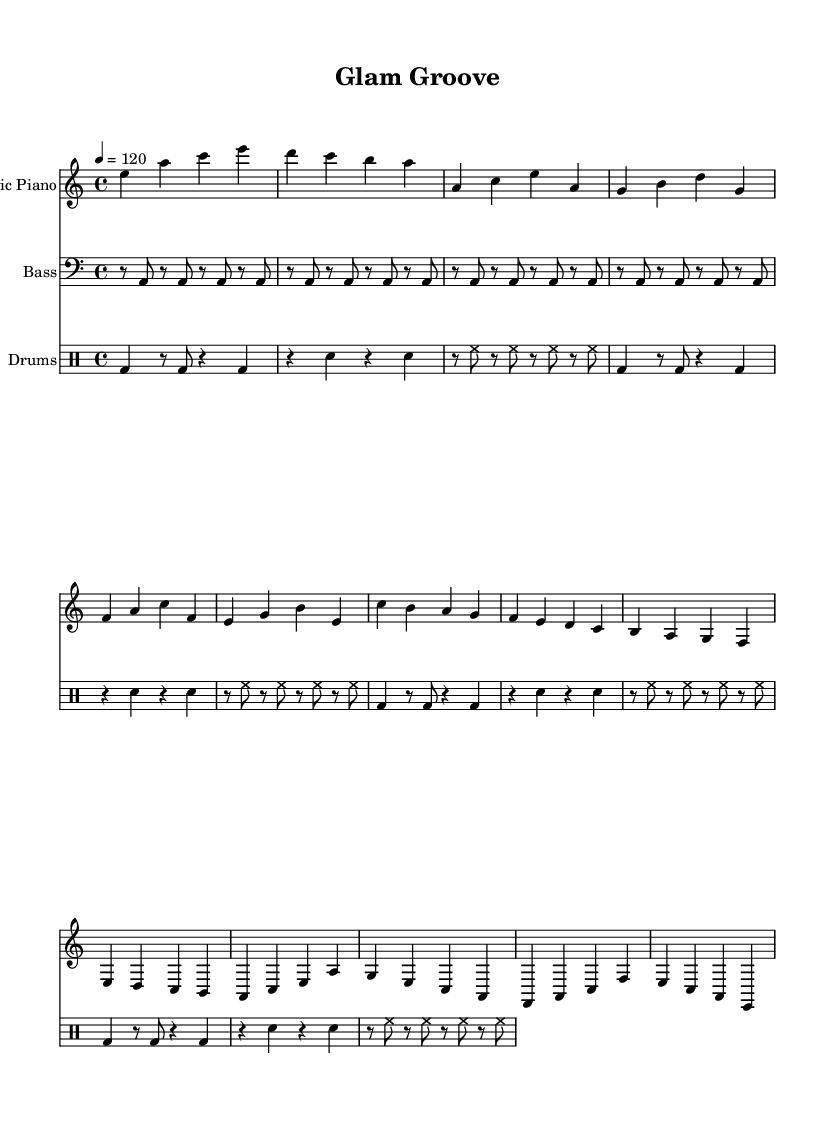What is the key signature of this music? The key signature is A minor, which has no sharps or flats. It is indicated at the beginning of the staff with the key signature symbol showing the absence of any accidentals.
Answer: A minor What is the time signature of this music? The time signature is 4/4, which is indicated at the start of the score. In this signature, there are four beats per measure and the quarter note gets one beat.
Answer: 4/4 What is the tempo marking for this piece? The tempo marking is 120, which is indicated in the tempo directive at the beginning of the score, specifying that the piece should be played at 120 beats per minute.
Answer: 120 How many measures are in the chorus section? The chorus section consists of 4 measures, which can be counted by looking at the notation and identifying the grouped measures for the chorus part specifically.
Answer: 4 Which instrument has the part written in treble clef? The electric piano has the part written in treble clef, as indicated by the clef symbol at the beginning of the electric piano staff.
Answer: Electric Piano What rhythmic pattern does the bass guitar predominantly use? The bass guitar predominantly uses a repeated pattern of quarter notes, with the specific notes being sustained across the measures, as indicated by the rhythmic notation shown.
Answer: Repeated quarter notes What genre does this piece of music represent? This piece of music represents disco-influenced dance music, as indicated by its groove and upbeat style along with the thematic elements of glamour and style present throughout the sections.
Answer: Disco-influenced dance music 